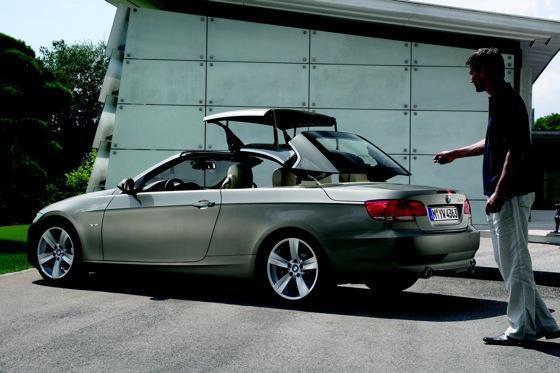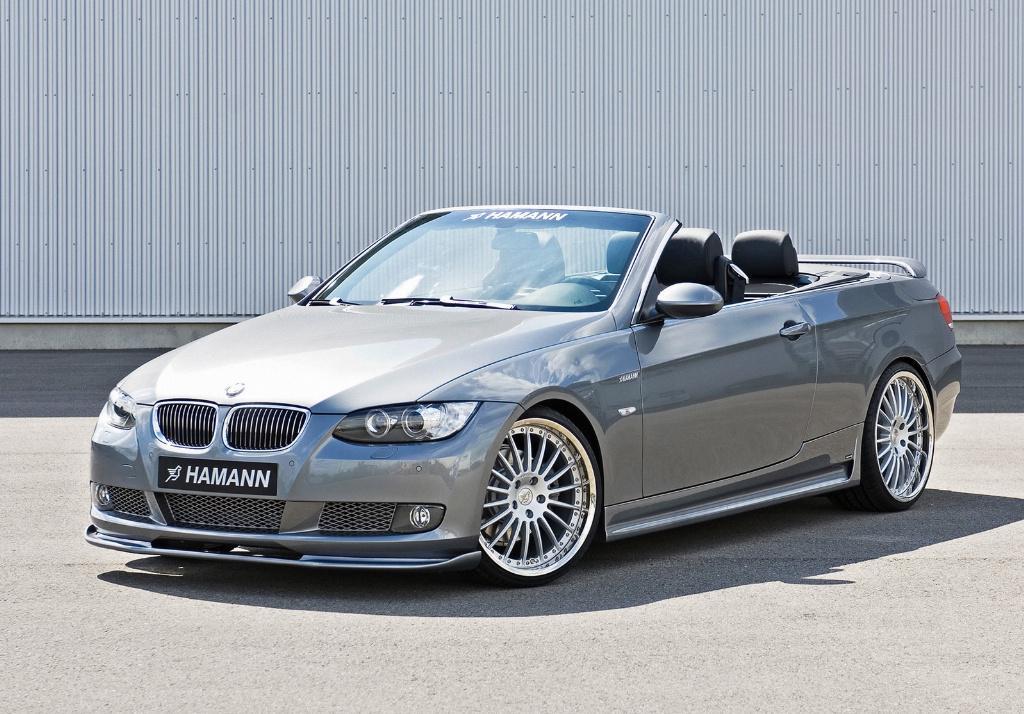The first image is the image on the left, the second image is the image on the right. Assess this claim about the two images: "In each image there is a convertible with its top down without any people present, but the cars are facing the opposite direction.". Correct or not? Answer yes or no. No. The first image is the image on the left, the second image is the image on the right. Assess this claim about the two images: "Each image contains one topless convertible displayed at an angle, and the cars on the left and right are back-to-back, facing outward.". Correct or not? Answer yes or no. No. 